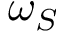Convert formula to latex. <formula><loc_0><loc_0><loc_500><loc_500>\omega _ { S }</formula> 